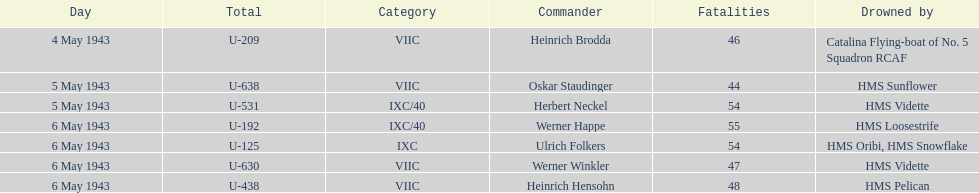What was the number of casualties on may 4 1943? 46. Would you be able to parse every entry in this table? {'header': ['Day', 'Total', 'Category', 'Commander', 'Fatalities', 'Drowned by'], 'rows': [['4 May 1943', 'U-209', 'VIIC', 'Heinrich Brodda', '46', 'Catalina Flying-boat of No. 5 Squadron RCAF'], ['5 May 1943', 'U-638', 'VIIC', 'Oskar Staudinger', '44', 'HMS Sunflower'], ['5 May 1943', 'U-531', 'IXC/40', 'Herbert Neckel', '54', 'HMS Vidette'], ['6 May 1943', 'U-192', 'IXC/40', 'Werner Happe', '55', 'HMS Loosestrife'], ['6 May 1943', 'U-125', 'IXC', 'Ulrich Folkers', '54', 'HMS Oribi, HMS Snowflake'], ['6 May 1943', 'U-630', 'VIIC', 'Werner Winkler', '47', 'HMS Vidette'], ['6 May 1943', 'U-438', 'VIIC', 'Heinrich Hensohn', '48', 'HMS Pelican']]} 